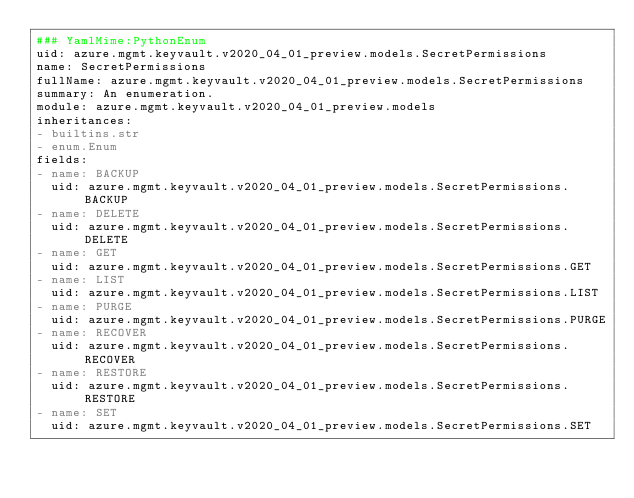Convert code to text. <code><loc_0><loc_0><loc_500><loc_500><_YAML_>### YamlMime:PythonEnum
uid: azure.mgmt.keyvault.v2020_04_01_preview.models.SecretPermissions
name: SecretPermissions
fullName: azure.mgmt.keyvault.v2020_04_01_preview.models.SecretPermissions
summary: An enumeration.
module: azure.mgmt.keyvault.v2020_04_01_preview.models
inheritances:
- builtins.str
- enum.Enum
fields:
- name: BACKUP
  uid: azure.mgmt.keyvault.v2020_04_01_preview.models.SecretPermissions.BACKUP
- name: DELETE
  uid: azure.mgmt.keyvault.v2020_04_01_preview.models.SecretPermissions.DELETE
- name: GET
  uid: azure.mgmt.keyvault.v2020_04_01_preview.models.SecretPermissions.GET
- name: LIST
  uid: azure.mgmt.keyvault.v2020_04_01_preview.models.SecretPermissions.LIST
- name: PURGE
  uid: azure.mgmt.keyvault.v2020_04_01_preview.models.SecretPermissions.PURGE
- name: RECOVER
  uid: azure.mgmt.keyvault.v2020_04_01_preview.models.SecretPermissions.RECOVER
- name: RESTORE
  uid: azure.mgmt.keyvault.v2020_04_01_preview.models.SecretPermissions.RESTORE
- name: SET
  uid: azure.mgmt.keyvault.v2020_04_01_preview.models.SecretPermissions.SET
</code> 